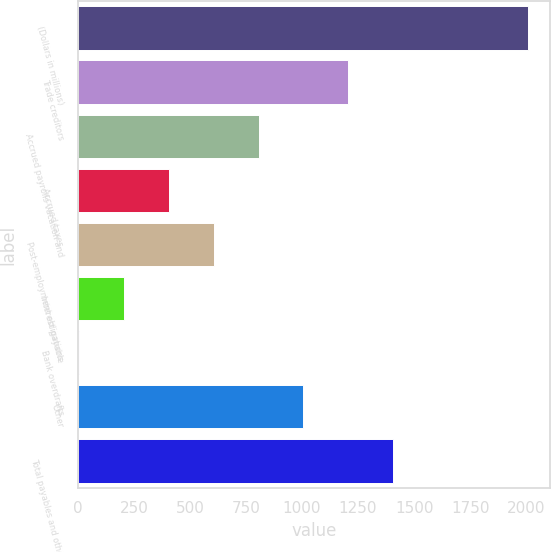<chart> <loc_0><loc_0><loc_500><loc_500><bar_chart><fcel>(Dollars in millions)<fcel>Trade creditors<fcel>Accrued payrolls vacation and<fcel>Accrued taxes<fcel>Post-employment obligations<fcel>Interest payable<fcel>Bank overdrafts<fcel>Other<fcel>Total payables and other<nl><fcel>2007<fcel>1206.6<fcel>806.4<fcel>406.2<fcel>606.3<fcel>206.1<fcel>6<fcel>1006.5<fcel>1406.7<nl></chart> 